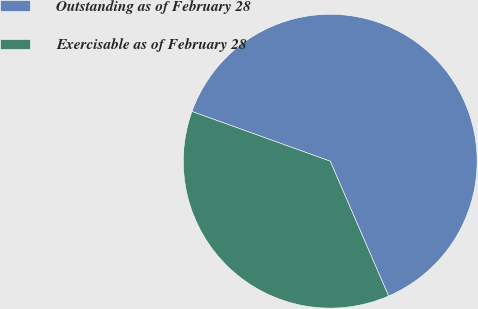Convert chart. <chart><loc_0><loc_0><loc_500><loc_500><pie_chart><fcel>Outstanding as of February 28<fcel>Exercisable as of February 28<nl><fcel>63.0%<fcel>37.0%<nl></chart> 